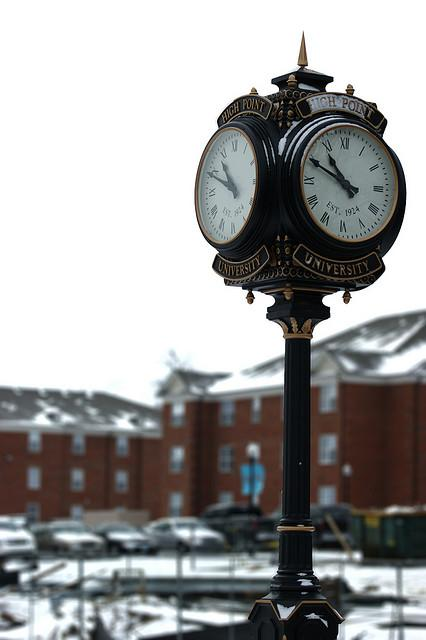This University is affiliated with what denomination? Please explain your reasoning. methodist. The university is methodist. 